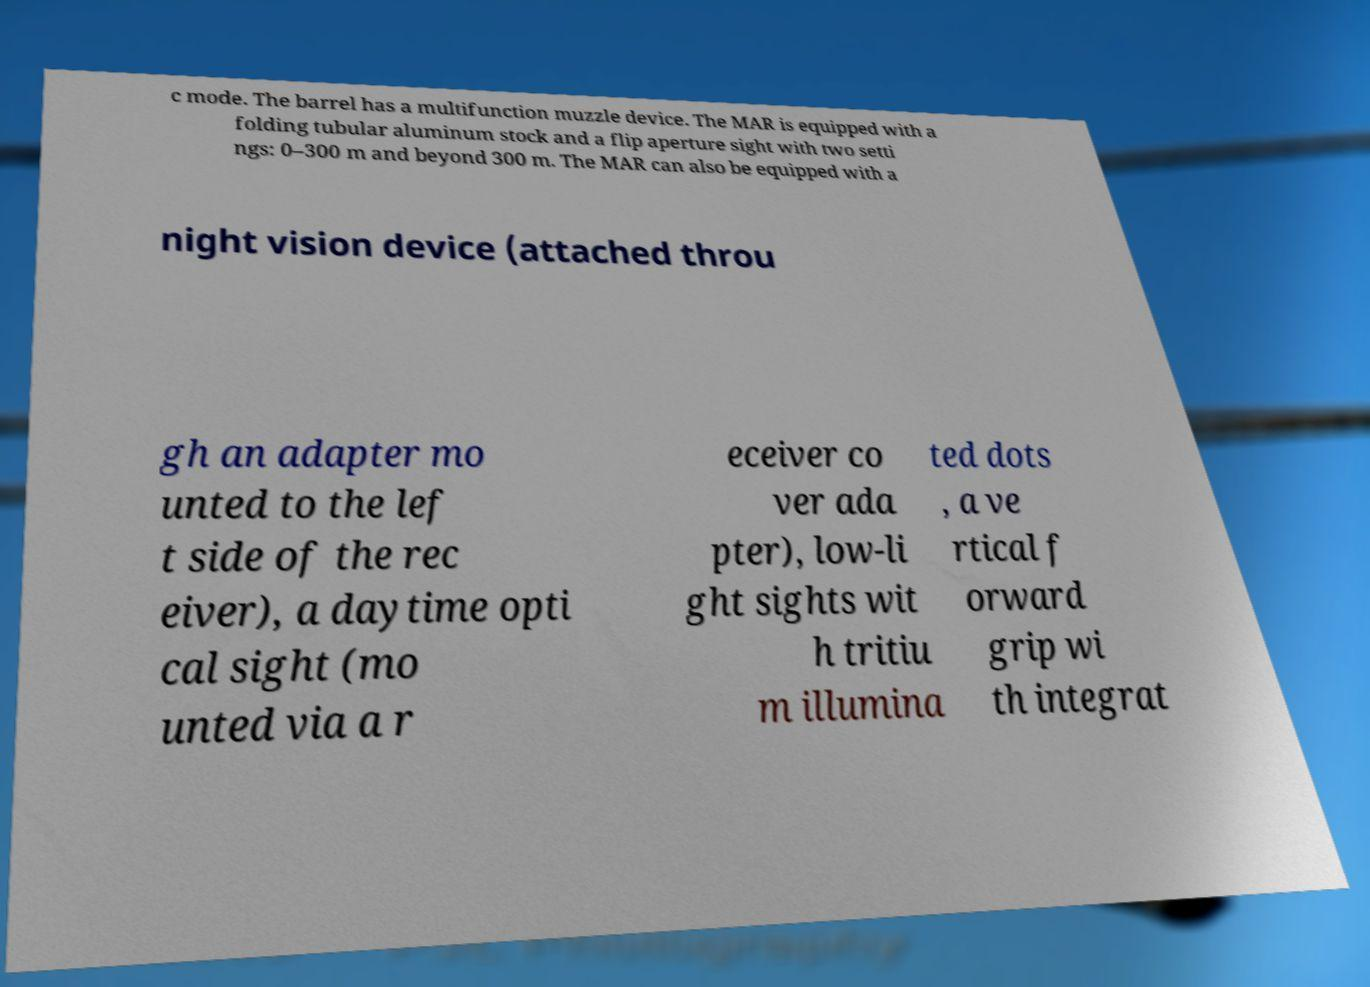What messages or text are displayed in this image? I need them in a readable, typed format. c mode. The barrel has a multifunction muzzle device. The MAR is equipped with a folding tubular aluminum stock and a flip aperture sight with two setti ngs: 0–300 m and beyond 300 m. The MAR can also be equipped with a night vision device (attached throu gh an adapter mo unted to the lef t side of the rec eiver), a daytime opti cal sight (mo unted via a r eceiver co ver ada pter), low-li ght sights wit h tritiu m illumina ted dots , a ve rtical f orward grip wi th integrat 